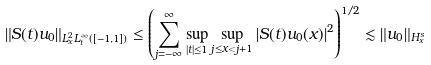Convert formula to latex. <formula><loc_0><loc_0><loc_500><loc_500>\left \| S ( t ) u _ { 0 } \right \| _ { L ^ { 2 } _ { x } L ^ { \infty } _ { t } ( [ - 1 , 1 ] ) } \leq \left ( \sum _ { j = - \infty } ^ { \infty } \sup _ { | t | \leq 1 } \sup _ { j \leq x < j + 1 } \left | S ( t ) u _ { 0 } ( x ) \right | ^ { 2 } \right ) ^ { 1 / 2 } \lesssim \| u _ { 0 } \| _ { H _ { x } ^ { s } }</formula> 